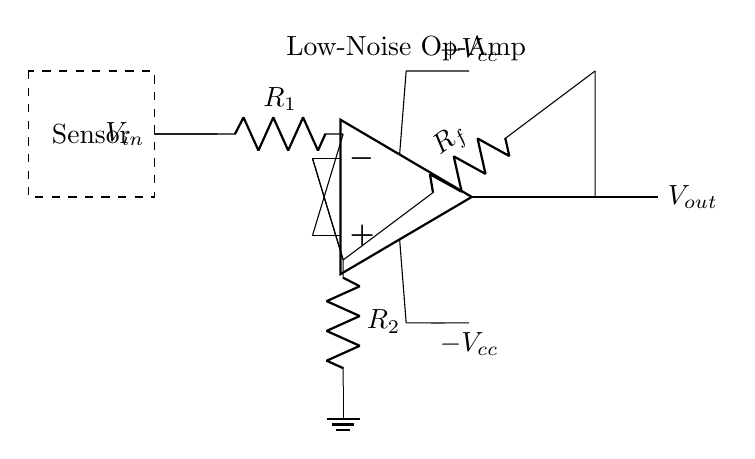What is the input voltage in this circuit? The input voltage is represented by \( V_{in} \), indicated on the left side of the circuit diagram.
Answer: V_in What type of operational amplifier is used in this circuit? The circuit specifically notes that it uses a Low-Noise Op-Amp, as labeled above the op-amp symbol in the diagram.
Answer: Low-Noise Op-Amp What are the resistor values in this circuit? The resistors in the circuit are labeled as \( R_1 \), \( R_f \), and \( R_2 \). Their specific values aren't given in the diagram, just their functions in the circuit.
Answer: R_1, R_f, R_2 Where is the output voltage taken from? The output voltage, labeled as \( V_{out} \), is taken from the output terminal of the op-amp on the right side of the circuit.
Answer: V_out What is the purpose of \( R_f \) in this circuit? \( R_f \) serves as the feedback resistor, which influences the gain of the operational amplifier by feeding back part of the output voltage to the negative input.
Answer: Feedback resistor How does the circuit handle negative voltage? The circuit connects to a negative voltage supply labeled \( -V_{cc} \), ensuring the op-amp can operate with both positive and negative voltage levels, which is essential for certain signal processing applications.
Answer: Negative voltage supply What is the main function of this circuit? The main function is to amplify low-level signals from sensitive environmental sensors, as suggested by its designation for smart office applications.
Answer: Signal amplification 